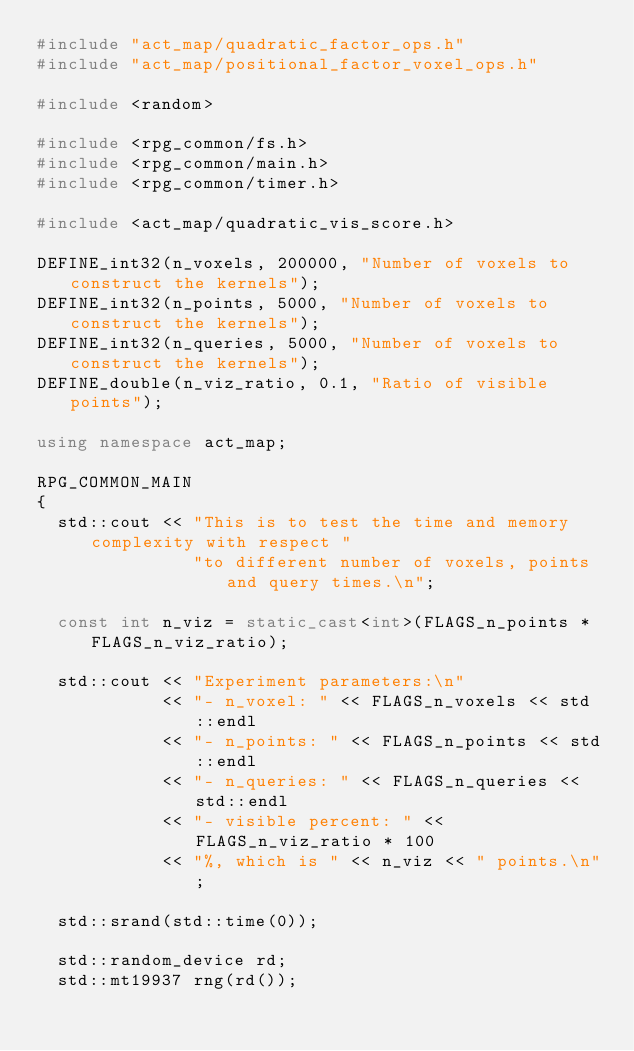Convert code to text. <code><loc_0><loc_0><loc_500><loc_500><_C++_>#include "act_map/quadratic_factor_ops.h"
#include "act_map/positional_factor_voxel_ops.h"

#include <random>

#include <rpg_common/fs.h>
#include <rpg_common/main.h>
#include <rpg_common/timer.h>

#include <act_map/quadratic_vis_score.h>

DEFINE_int32(n_voxels, 200000, "Number of voxels to construct the kernels");
DEFINE_int32(n_points, 5000, "Number of voxels to construct the kernels");
DEFINE_int32(n_queries, 5000, "Number of voxels to construct the kernels");
DEFINE_double(n_viz_ratio, 0.1, "Ratio of visible points");

using namespace act_map;

RPG_COMMON_MAIN
{
  std::cout << "This is to test the time and memory complexity with respect "
               "to different number of voxels, points and query times.\n";

  const int n_viz = static_cast<int>(FLAGS_n_points * FLAGS_n_viz_ratio);

  std::cout << "Experiment parameters:\n"
            << "- n_voxel: " << FLAGS_n_voxels << std::endl
            << "- n_points: " << FLAGS_n_points << std::endl
            << "- n_queries: " << FLAGS_n_queries << std::endl
            << "- visible percent: " << FLAGS_n_viz_ratio * 100
            << "%, which is " << n_viz << " points.\n";

  std::srand(std::time(0));

  std::random_device rd;
  std::mt19937 rng(rd());</code> 